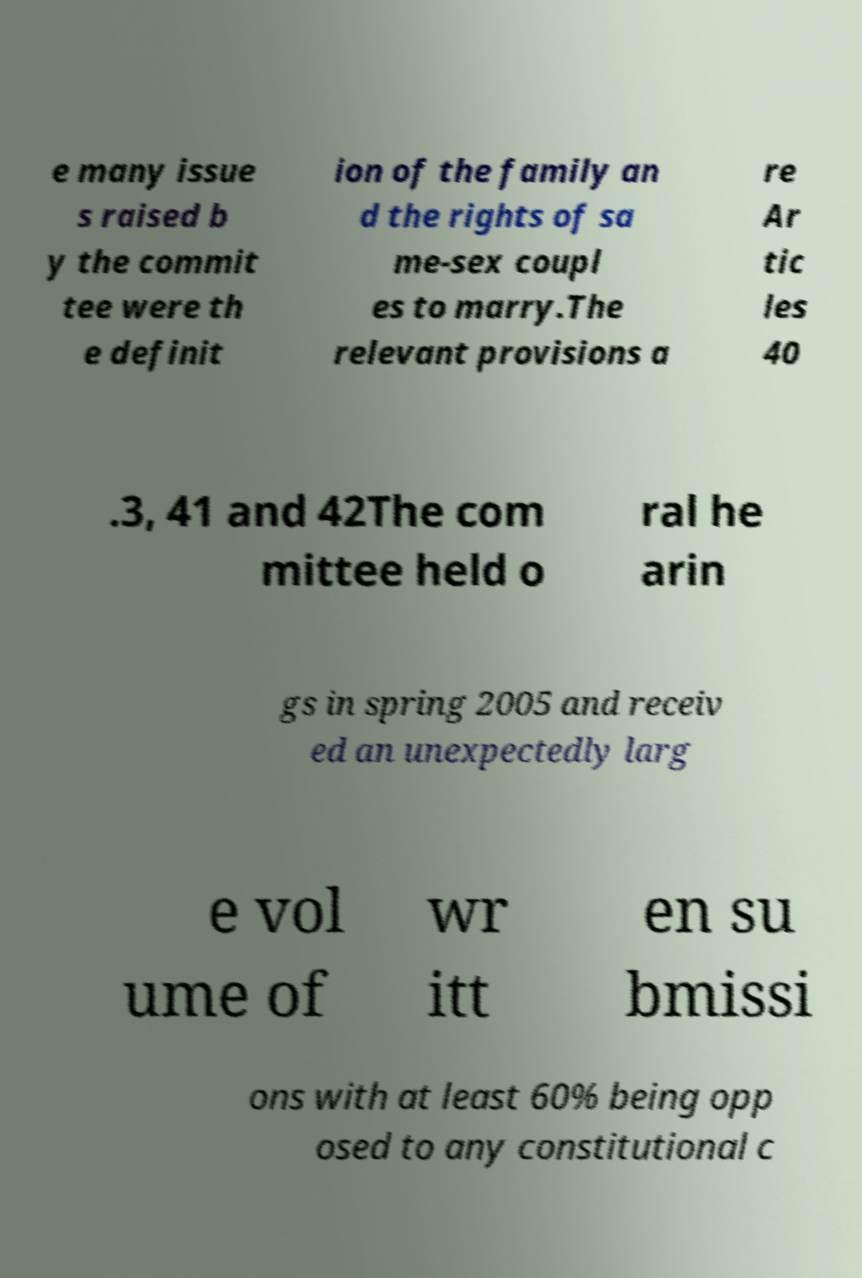There's text embedded in this image that I need extracted. Can you transcribe it verbatim? e many issue s raised b y the commit tee were th e definit ion of the family an d the rights of sa me-sex coupl es to marry.The relevant provisions a re Ar tic les 40 .3, 41 and 42The com mittee held o ral he arin gs in spring 2005 and receiv ed an unexpectedly larg e vol ume of wr itt en su bmissi ons with at least 60% being opp osed to any constitutional c 